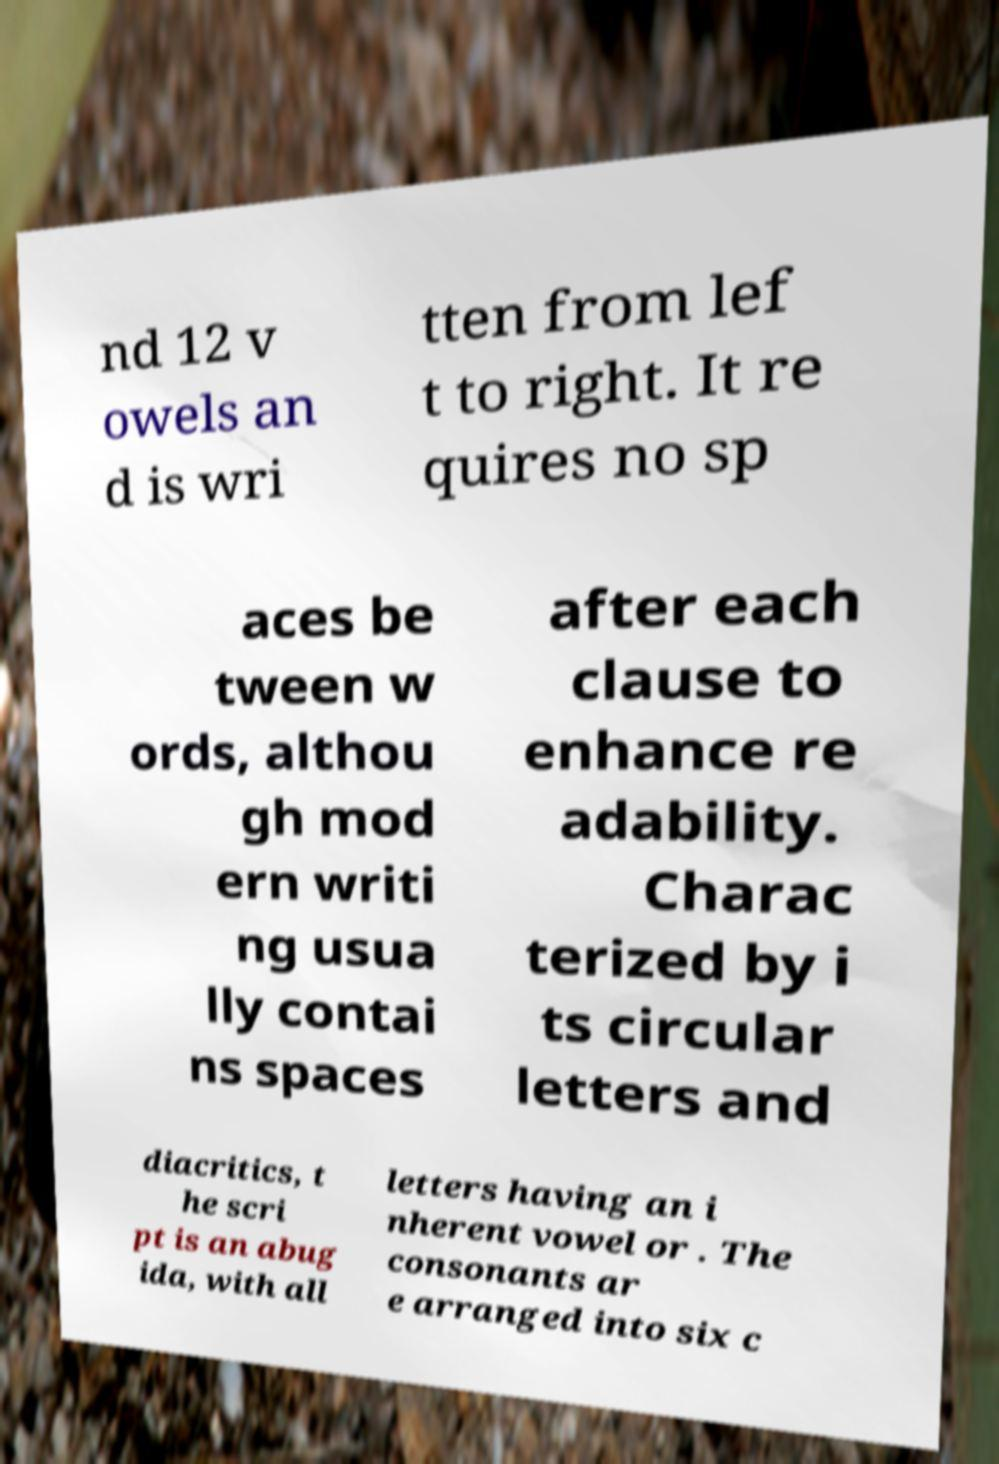There's text embedded in this image that I need extracted. Can you transcribe it verbatim? nd 12 v owels an d is wri tten from lef t to right. It re quires no sp aces be tween w ords, althou gh mod ern writi ng usua lly contai ns spaces after each clause to enhance re adability. Charac terized by i ts circular letters and diacritics, t he scri pt is an abug ida, with all letters having an i nherent vowel or . The consonants ar e arranged into six c 